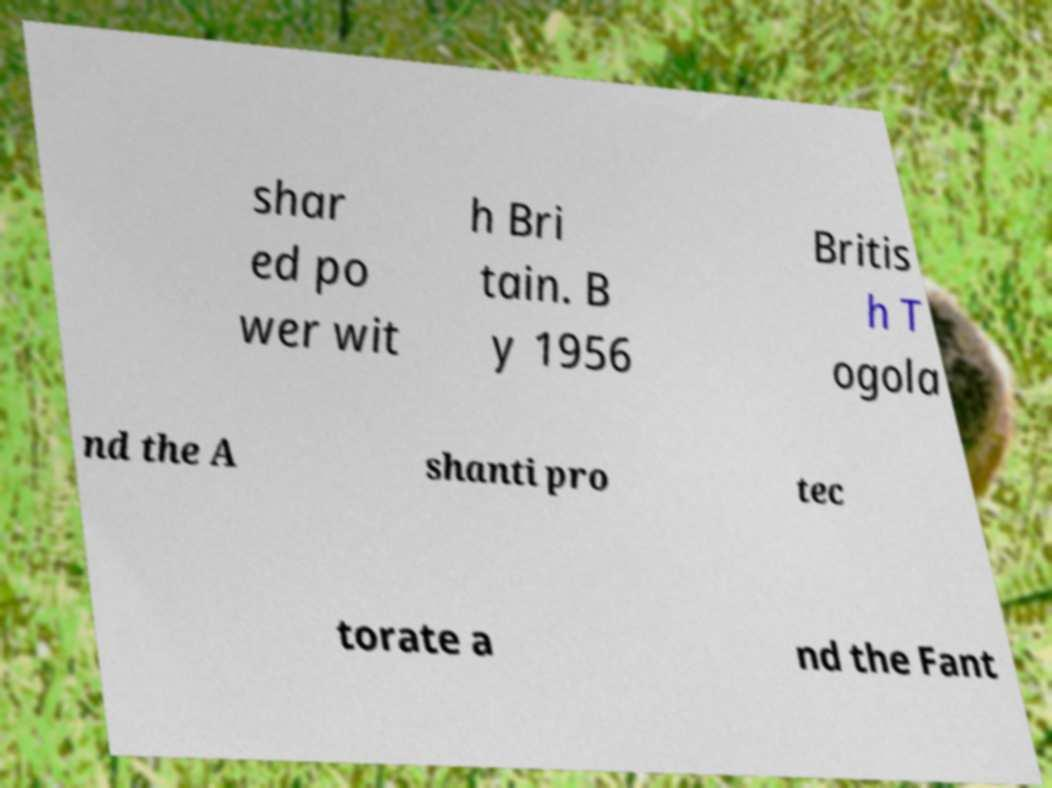Can you read and provide the text displayed in the image?This photo seems to have some interesting text. Can you extract and type it out for me? shar ed po wer wit h Bri tain. B y 1956 Britis h T ogola nd the A shanti pro tec torate a nd the Fant 